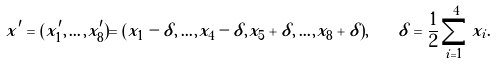<formula> <loc_0><loc_0><loc_500><loc_500>x ^ { \prime } = ( x _ { 1 } ^ { \prime } , \dots , x _ { 8 } ^ { \prime } ) = ( x _ { 1 } - \delta , \dots , x _ { 4 } - \delta , x _ { 5 } + \delta , \dots , x _ { 8 } + \delta ) , \quad \delta = \frac { 1 } { 2 } \sum _ { i = 1 } ^ { 4 } x _ { i } .</formula> 